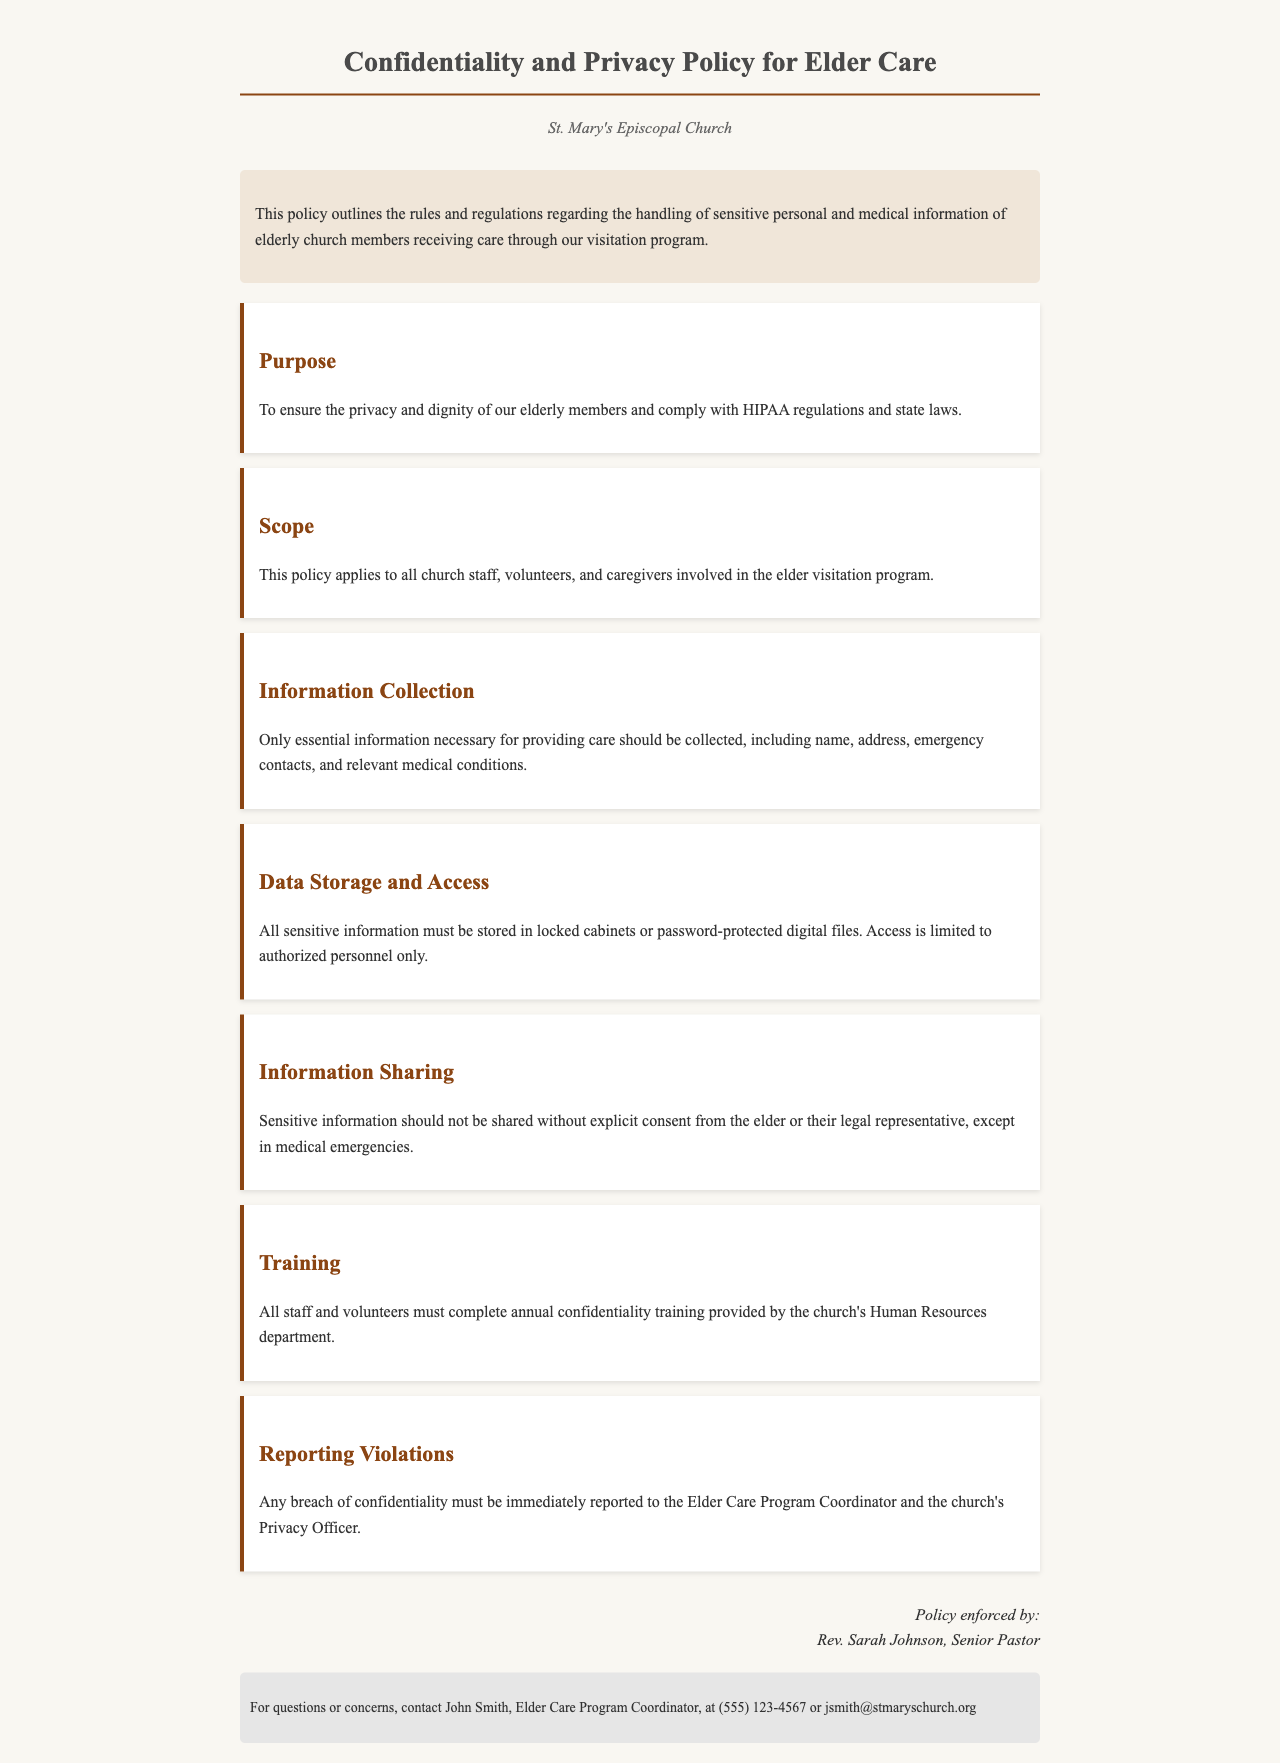what is the title of the document? The title is stated at the top of the document as "Confidentiality and Privacy Policy for Elder Care."
Answer: Confidentiality and Privacy Policy for Elder Care who is the policy enforced by? The document includes a signature section that identifies the enforcer as Rev. Sarah Johnson.
Answer: Rev. Sarah Johnson what is the purpose of the policy? The purpose of the policy is outlined in the "Purpose" section, stating it is to ensure privacy and comply with regulations.
Answer: To ensure the privacy and dignity of our elderly members and comply with HIPAA regulations and state laws who should complete the annual confidentiality training? The "Training" section specifies that all staff and volunteers must complete this training.
Answer: All staff and volunteers what should be done in case of a confidentiality breach? The document specifies that any breach must be reported to the Elder Care Program Coordinator and the Privacy Officer.
Answer: Reported to the Elder Care Program Coordinator and the Privacy Officer what type of information can be collected? The "Information Collection" section indicates that only essential information necessary for care should be collected.
Answer: Only essential information necessary for providing care who can access sensitive information? The "Data Storage and Access" section mentions that access is limited to authorized personnel only.
Answer: Authorized personnel only what must be obtained before sharing sensitive information? The "Information Sharing" section clarifies that explicit consent must be obtained from the elder or their legal representative.
Answer: Explicit consent 